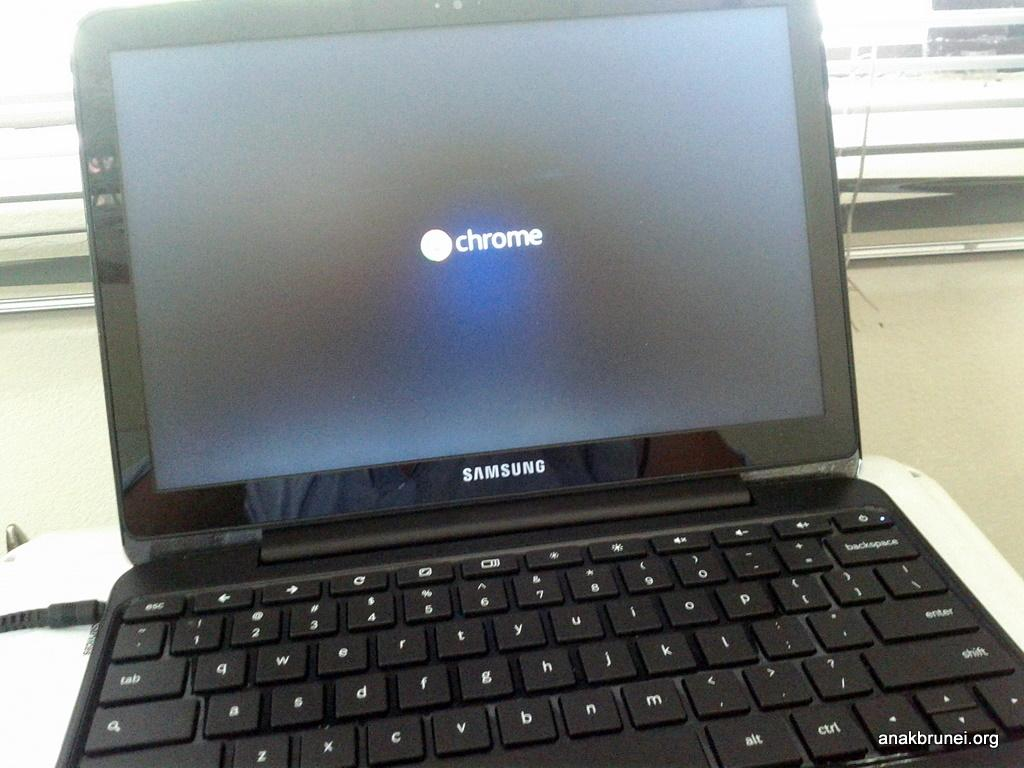<image>
Relay a brief, clear account of the picture shown. A Samsung laptop sitting on desk and the word Chrome on the screen. 